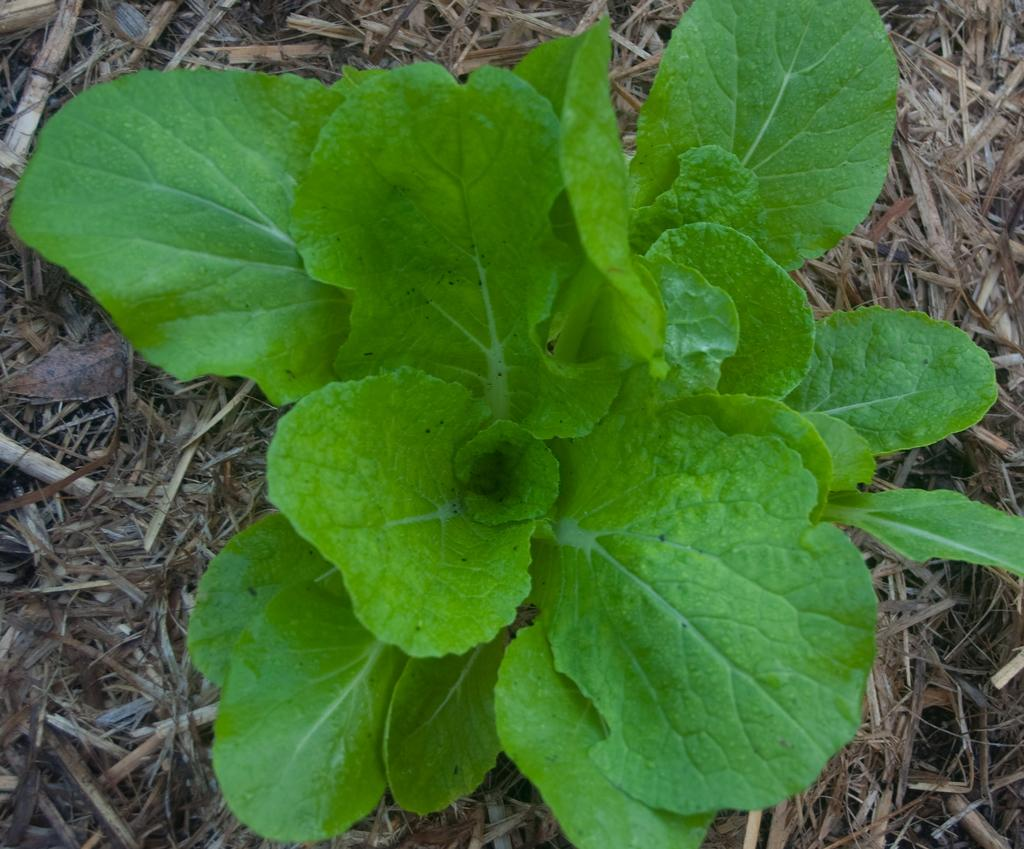What type of vegetation is present in the image? The image contains green leaves. What is visible beneath the vegetation? There is ground visible in the image. What is the condition of the grass at the bottom of the image? Dry grass is present at the bottom of the image. What grade did the pets receive on their report card in the image? There are no pets or report cards present in the image. How many dimes can be seen on the ground in the image? There are no dimes visible in the image; it only contains green leaves, ground, and dry grass. 